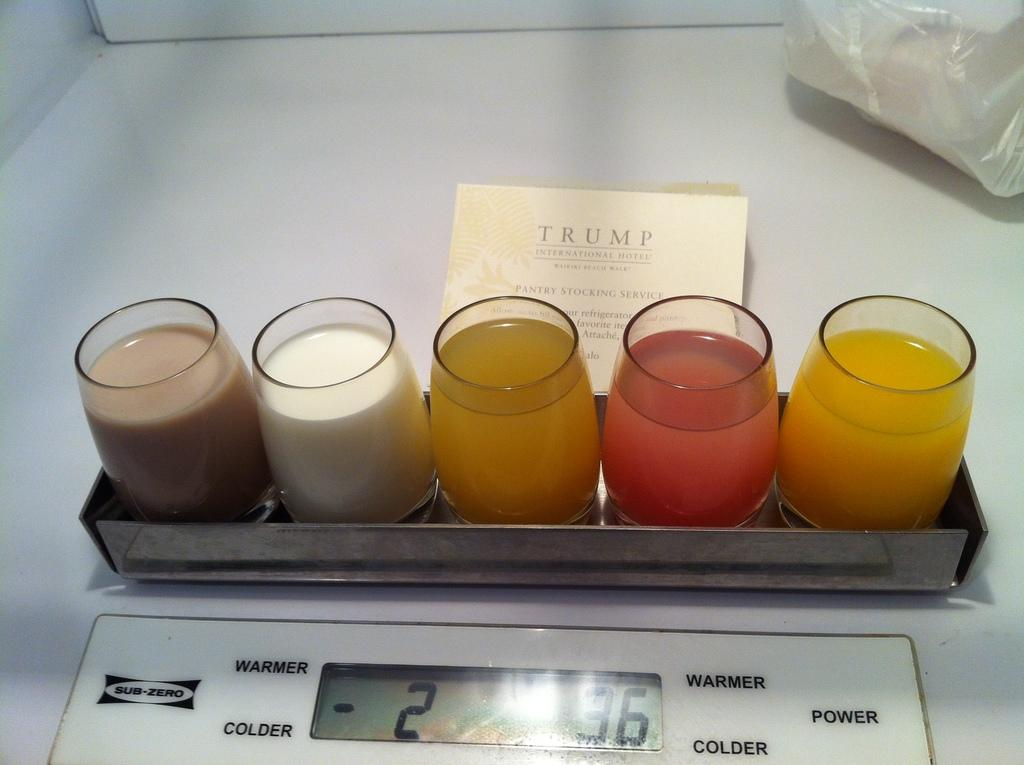What is located in the foreground of the image? There is a tray in the foreground of the image. What is on the tray? Juice glasses are present on the tray. What other object can be seen in the image? A weighing machine is visible in the image. Where might this image have been taken? The image is likely taken in a room. What type of cheese is being weighed on the weighing machine in the image? There is no cheese present in the image, and the weighing machine is not being used to weigh any cheese. 